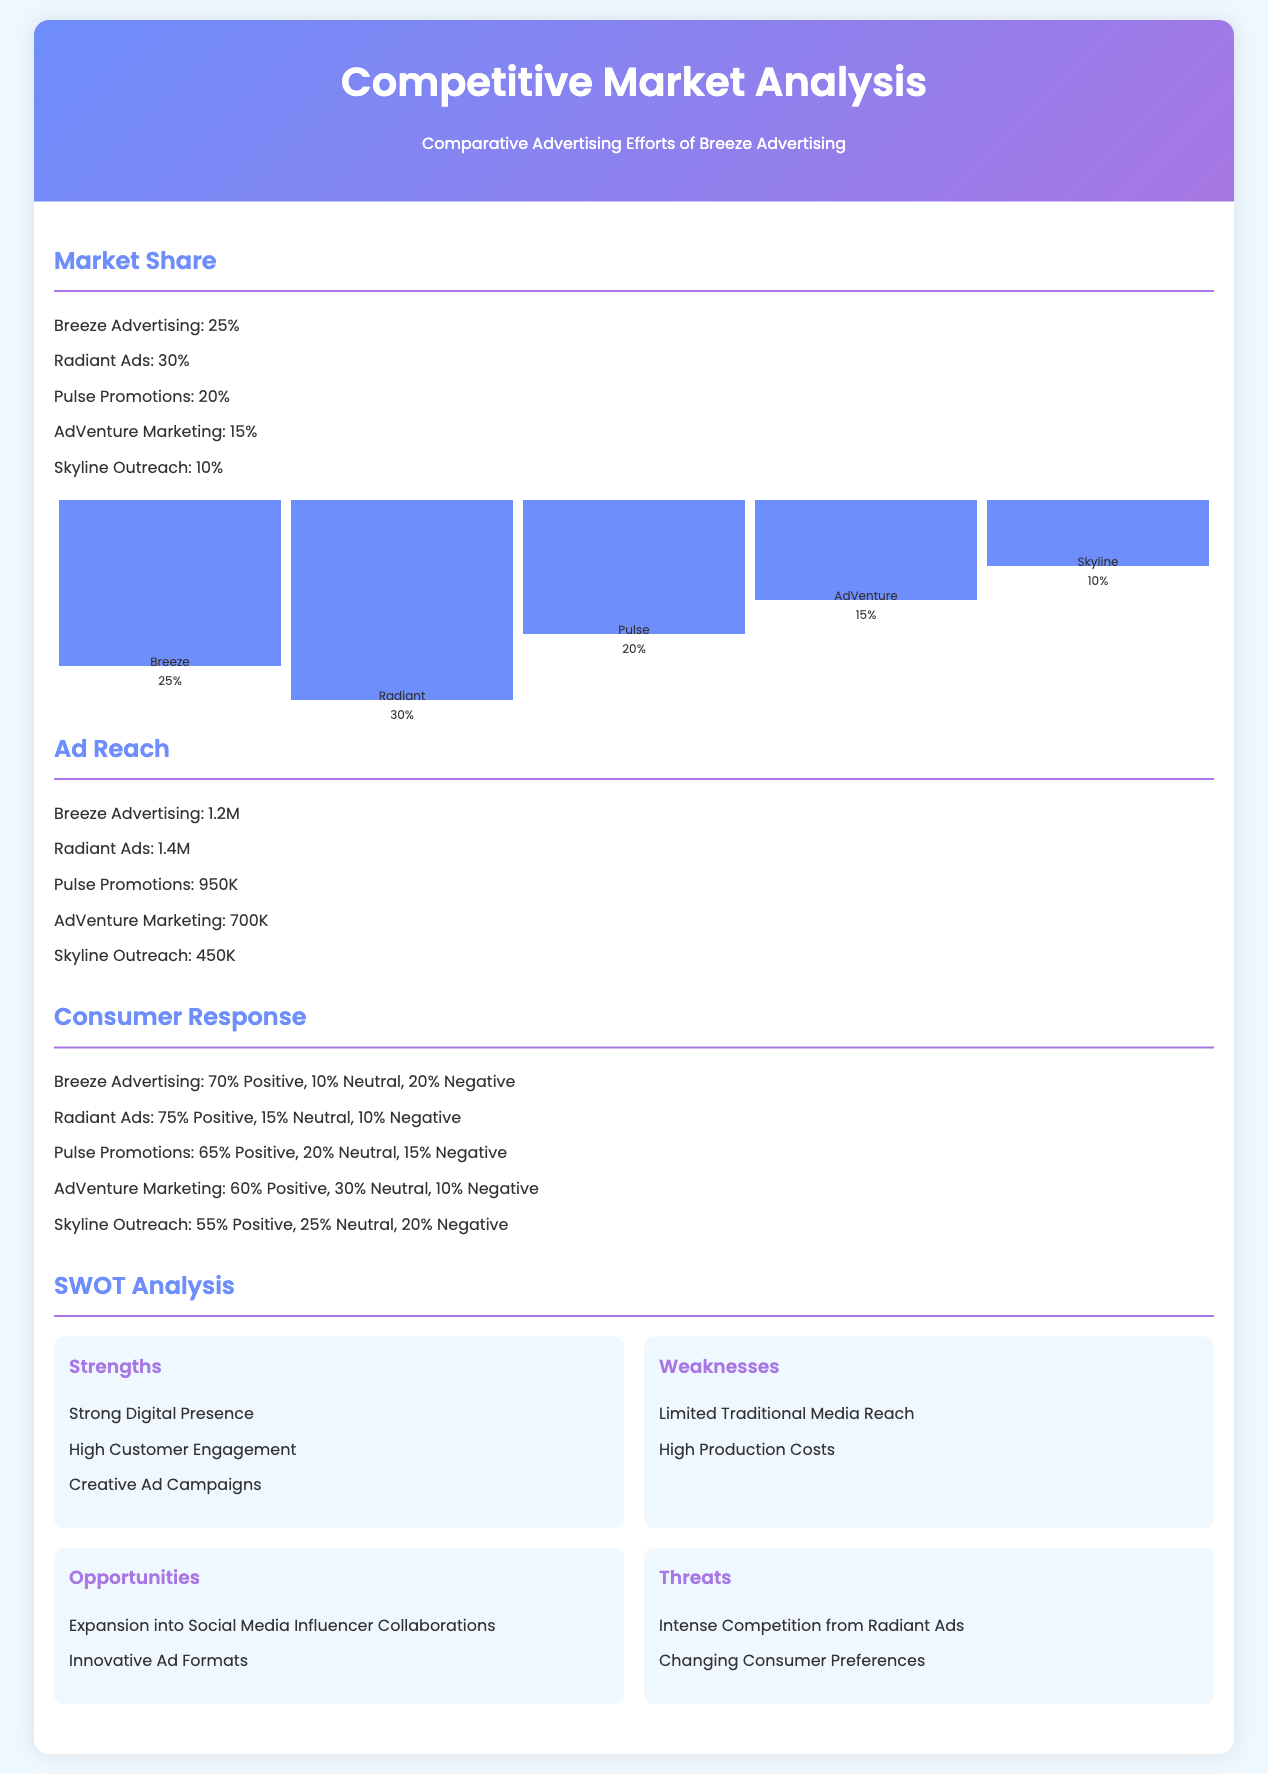What is Breeze Advertising's market share? The market share is specifically stated as 25% for Breeze Advertising in the document.
Answer: 25% Who has the highest ad reach? The document lists ad reach figures, identifying Radiant Ads as having the highest reach at 1.4M.
Answer: Radiant Ads What percentage of consumer response is positive for Pulse Promotions? The document notes that 65% of consumer responses for Pulse Promotions are positive.
Answer: 65% What is one of the strengths listed for Breeze Advertising? The document highlights several strengths, including "Strong Digital Presence."
Answer: Strong Digital Presence What percentage of negative responses does Skyline Outreach have? The document indicates that Skyline Outreach has 20% negative responses.
Answer: 20% Which competitor has the lowest market share? The market share section reveals that Skyline Outreach has the lowest market share at 10%.
Answer: Skyline Outreach What opportunity is mentioned for Breeze Advertising? "Expansion into Social Media Influencer Collaborations" is listed as an opportunity.
Answer: Expansion into Social Media Influencer Collaborations What is the percentage of neutral responses for Radiant Ads? The document states that 15% of responses for Radiant Ads are neutral.
Answer: 15% What is the overall theme of the document? The primary focus of the document is a competitive analysis of advertising efforts comparing different companies.
Answer: Competitive Market Analysis 